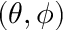<formula> <loc_0><loc_0><loc_500><loc_500>( \theta , \phi )</formula> 